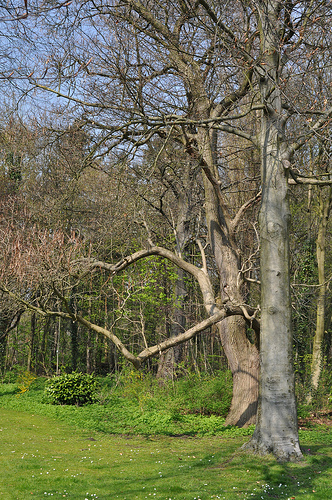<image>
Is the tree behind the tree? No. The tree is not behind the tree. From this viewpoint, the tree appears to be positioned elsewhere in the scene. 